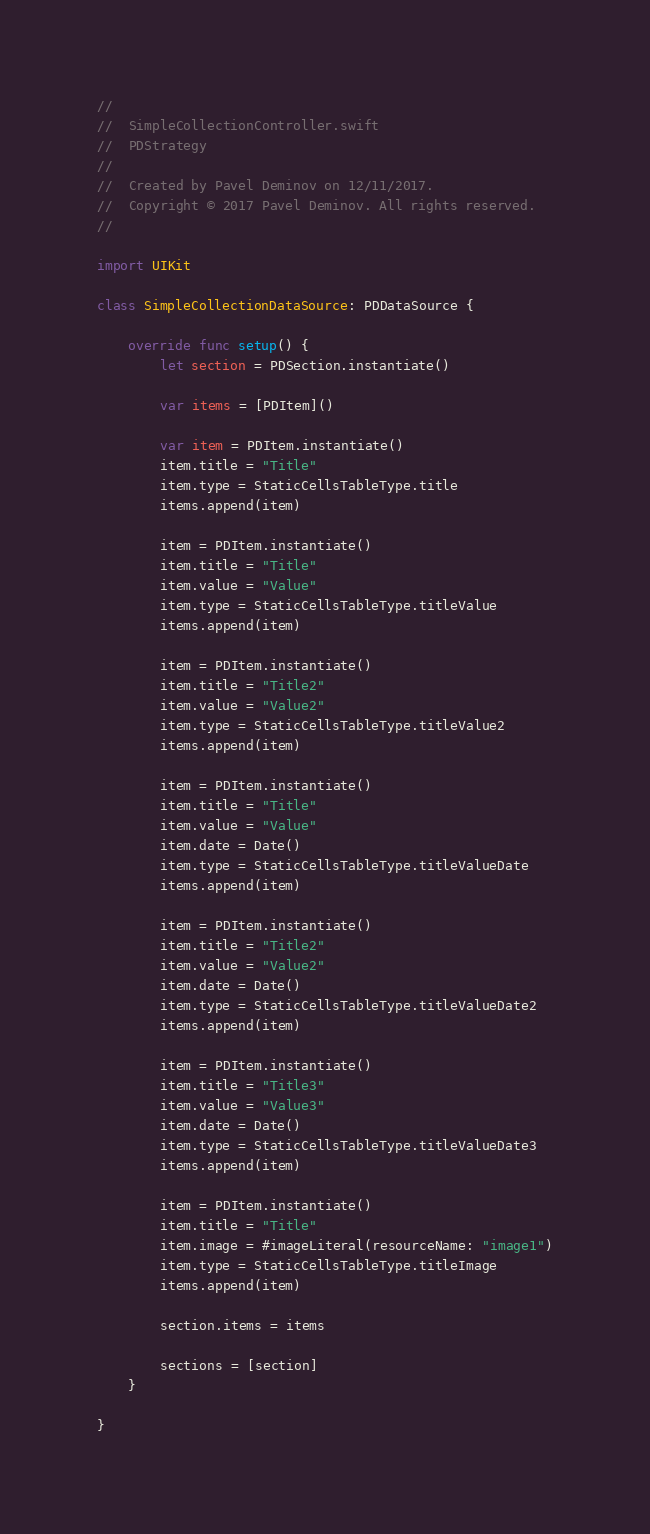Convert code to text. <code><loc_0><loc_0><loc_500><loc_500><_Swift_>//
//  SimpleCollectionController.swift
//  PDStrategy
//
//  Created by Pavel Deminov on 12/11/2017.
//  Copyright © 2017 Pavel Deminov. All rights reserved.
//

import UIKit

class SimpleCollectionDataSource: PDDataSource {
    
    override func setup() {
        let section = PDSection.instantiate()
        
        var items = [PDItem]()
        
        var item = PDItem.instantiate()
        item.title = "Title"
        item.type = StaticCellsTableType.title
        items.append(item)
        
        item = PDItem.instantiate()
        item.title = "Title"
        item.value = "Value"
        item.type = StaticCellsTableType.titleValue
        items.append(item)
        
        item = PDItem.instantiate()
        item.title = "Title2"
        item.value = "Value2"
        item.type = StaticCellsTableType.titleValue2
        items.append(item)
        
        item = PDItem.instantiate()
        item.title = "Title"
        item.value = "Value"
        item.date = Date()
        item.type = StaticCellsTableType.titleValueDate
        items.append(item)
        
        item = PDItem.instantiate()
        item.title = "Title2"
        item.value = "Value2"
        item.date = Date()
        item.type = StaticCellsTableType.titleValueDate2
        items.append(item)
        
        item = PDItem.instantiate()
        item.title = "Title3"
        item.value = "Value3"
        item.date = Date()
        item.type = StaticCellsTableType.titleValueDate3
        items.append(item)
        
        item = PDItem.instantiate()
        item.title = "Title"
        item.image = #imageLiteral(resourceName: "image1")
        item.type = StaticCellsTableType.titleImage
        items.append(item)
        
        section.items = items
        
        sections = [section]
    }
    
}
</code> 